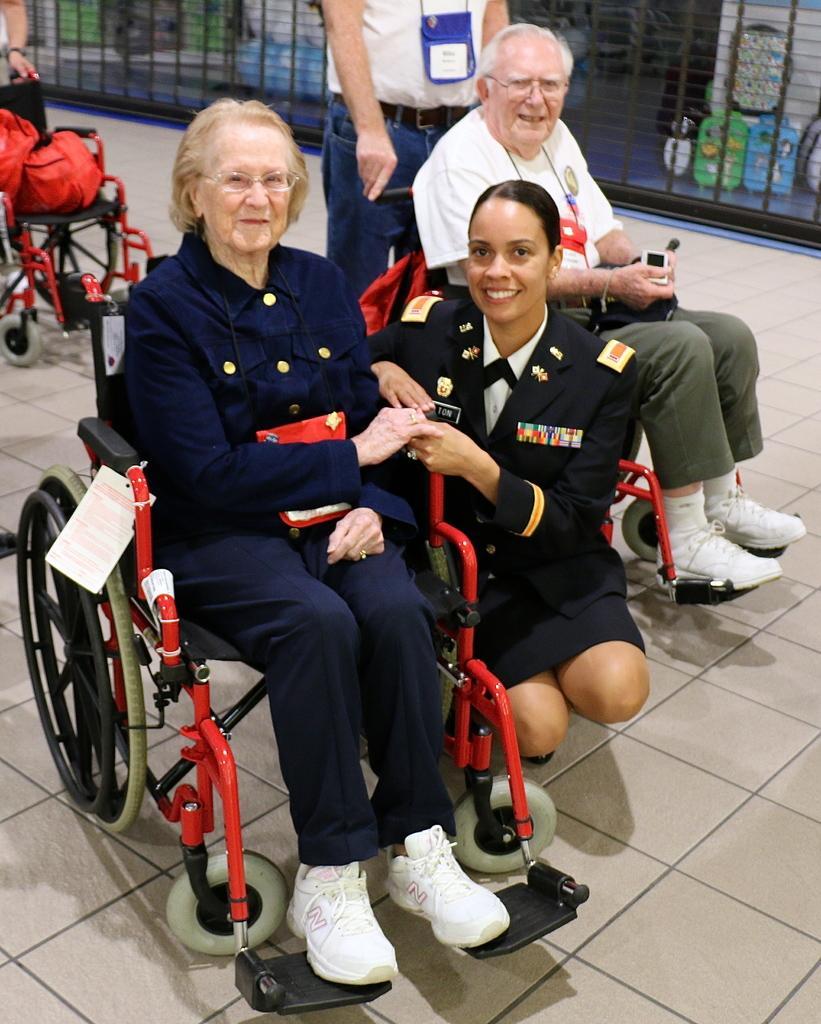Could you give a brief overview of what you see in this image? In this image there is a woman and a man sitting on the wheelchairs. Beside the woman there is another woman in squat position. Behind the man there is another man standing. To the left there are bags on the wheelchair. In the background there is a net. At the bottom there is the floor. 